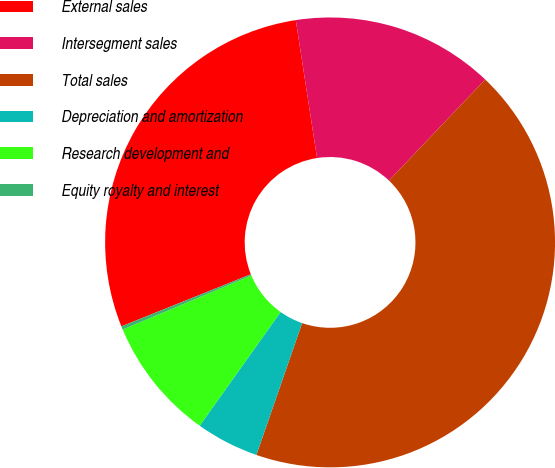<chart> <loc_0><loc_0><loc_500><loc_500><pie_chart><fcel>External sales<fcel>Intersegment sales<fcel>Total sales<fcel>Depreciation and amortization<fcel>Research development and<fcel>Equity royalty and interest<nl><fcel>28.65%<fcel>14.55%<fcel>43.2%<fcel>4.53%<fcel>8.83%<fcel>0.24%<nl></chart> 